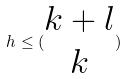Convert formula to latex. <formula><loc_0><loc_0><loc_500><loc_500>h \leq ( \begin{matrix} k + l \\ k \end{matrix} )</formula> 